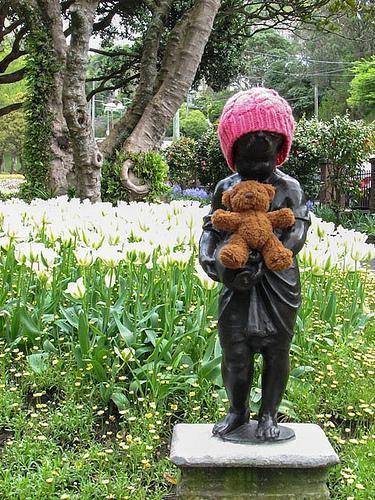How many teddy bears the statue holding?
Give a very brief answer. 1. How many statues?
Give a very brief answer. 1. 